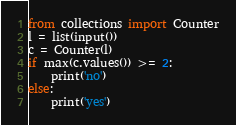Convert code to text. <code><loc_0><loc_0><loc_500><loc_500><_Python_>from collections import Counter
l = list(input())
c = Counter(l)
if max(c.values()) >= 2:
    print('no')
else:
    print('yes')</code> 